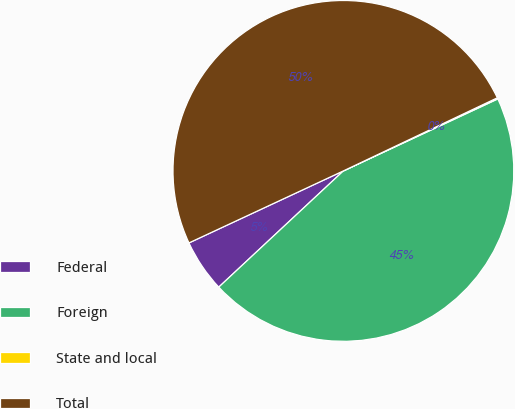Convert chart. <chart><loc_0><loc_0><loc_500><loc_500><pie_chart><fcel>Federal<fcel>Foreign<fcel>State and local<fcel>Total<nl><fcel>5.0%<fcel>45.0%<fcel>0.11%<fcel>49.89%<nl></chart> 